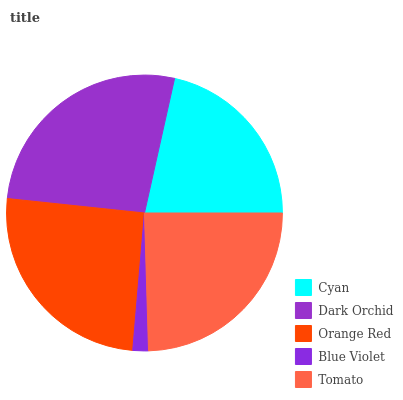Is Blue Violet the minimum?
Answer yes or no. Yes. Is Dark Orchid the maximum?
Answer yes or no. Yes. Is Orange Red the minimum?
Answer yes or no. No. Is Orange Red the maximum?
Answer yes or no. No. Is Dark Orchid greater than Orange Red?
Answer yes or no. Yes. Is Orange Red less than Dark Orchid?
Answer yes or no. Yes. Is Orange Red greater than Dark Orchid?
Answer yes or no. No. Is Dark Orchid less than Orange Red?
Answer yes or no. No. Is Tomato the high median?
Answer yes or no. Yes. Is Tomato the low median?
Answer yes or no. Yes. Is Dark Orchid the high median?
Answer yes or no. No. Is Cyan the low median?
Answer yes or no. No. 